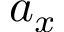Convert formula to latex. <formula><loc_0><loc_0><loc_500><loc_500>a _ { x }</formula> 